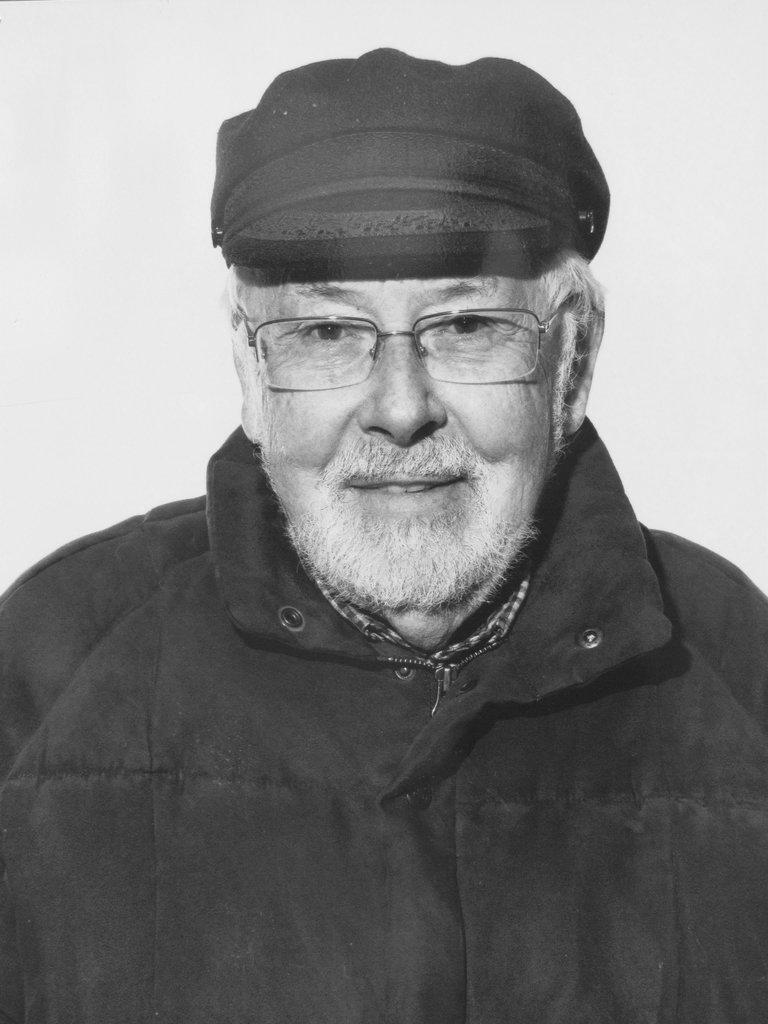What is the color scheme of the image? The image is black and white. Can you describe the person in the image? The person in the image is wearing spectacles and a cap. What is the background of the image? There is a white background behind the person. What type of drink is the person holding in the image? There is no drink visible in the image. What division does the person belong to in the image? There is no indication of any divisions or groups in the image. 